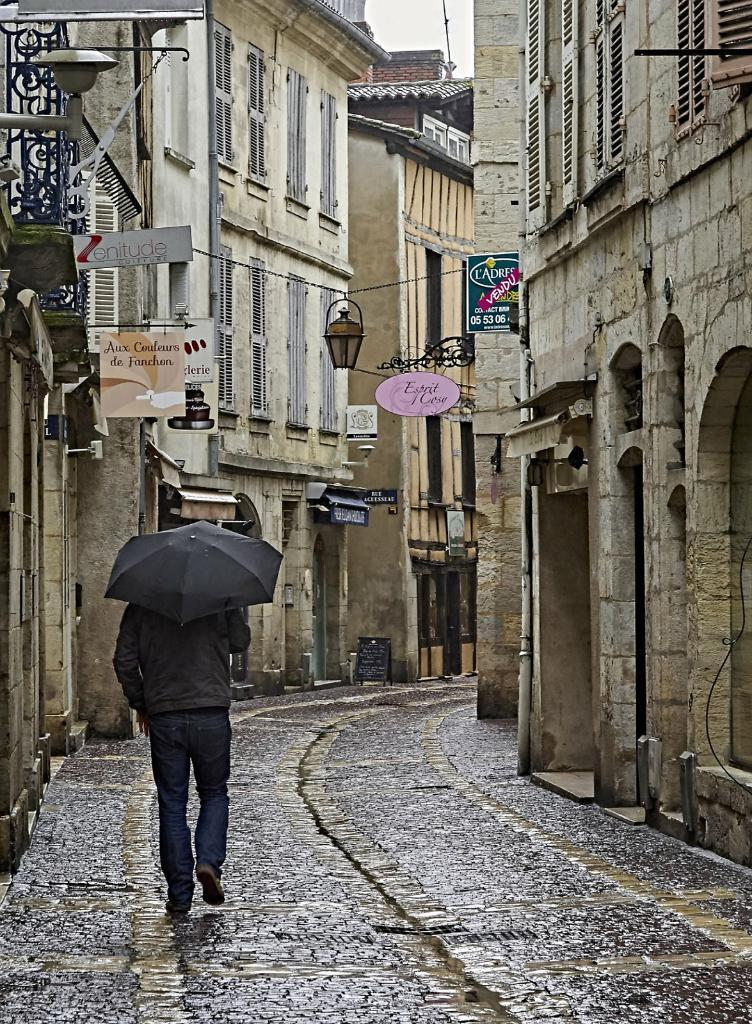What type of structures can be seen in the image? There are buildings in the image. What else is present in the image besides the buildings? There are boards with text and a human holding an umbrella in the image. What is the human doing in the image? The human is walking in the image. Can you find the agreement between the two parties in the image? There is no agreement between two parties present in the image. Is there a notebook visible in the image? There is no notebook visible in the image. 